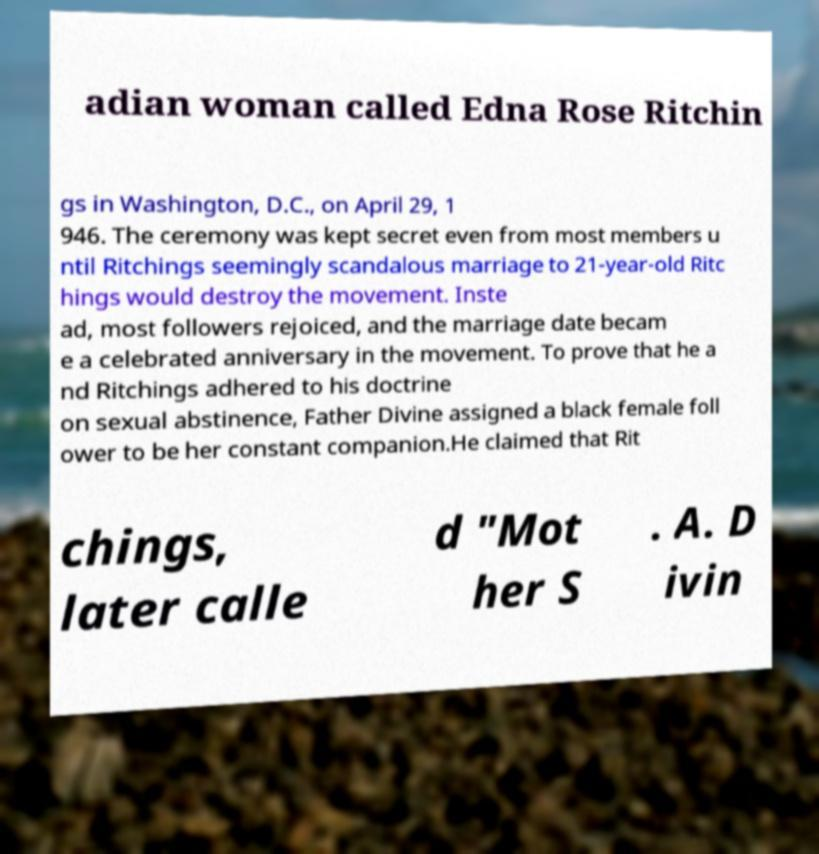There's text embedded in this image that I need extracted. Can you transcribe it verbatim? adian woman called Edna Rose Ritchin gs in Washington, D.C., on April 29, 1 946. The ceremony was kept secret even from most members u ntil Ritchings seemingly scandalous marriage to 21-year-old Ritc hings would destroy the movement. Inste ad, most followers rejoiced, and the marriage date becam e a celebrated anniversary in the movement. To prove that he a nd Ritchings adhered to his doctrine on sexual abstinence, Father Divine assigned a black female foll ower to be her constant companion.He claimed that Rit chings, later calle d "Mot her S . A. D ivin 